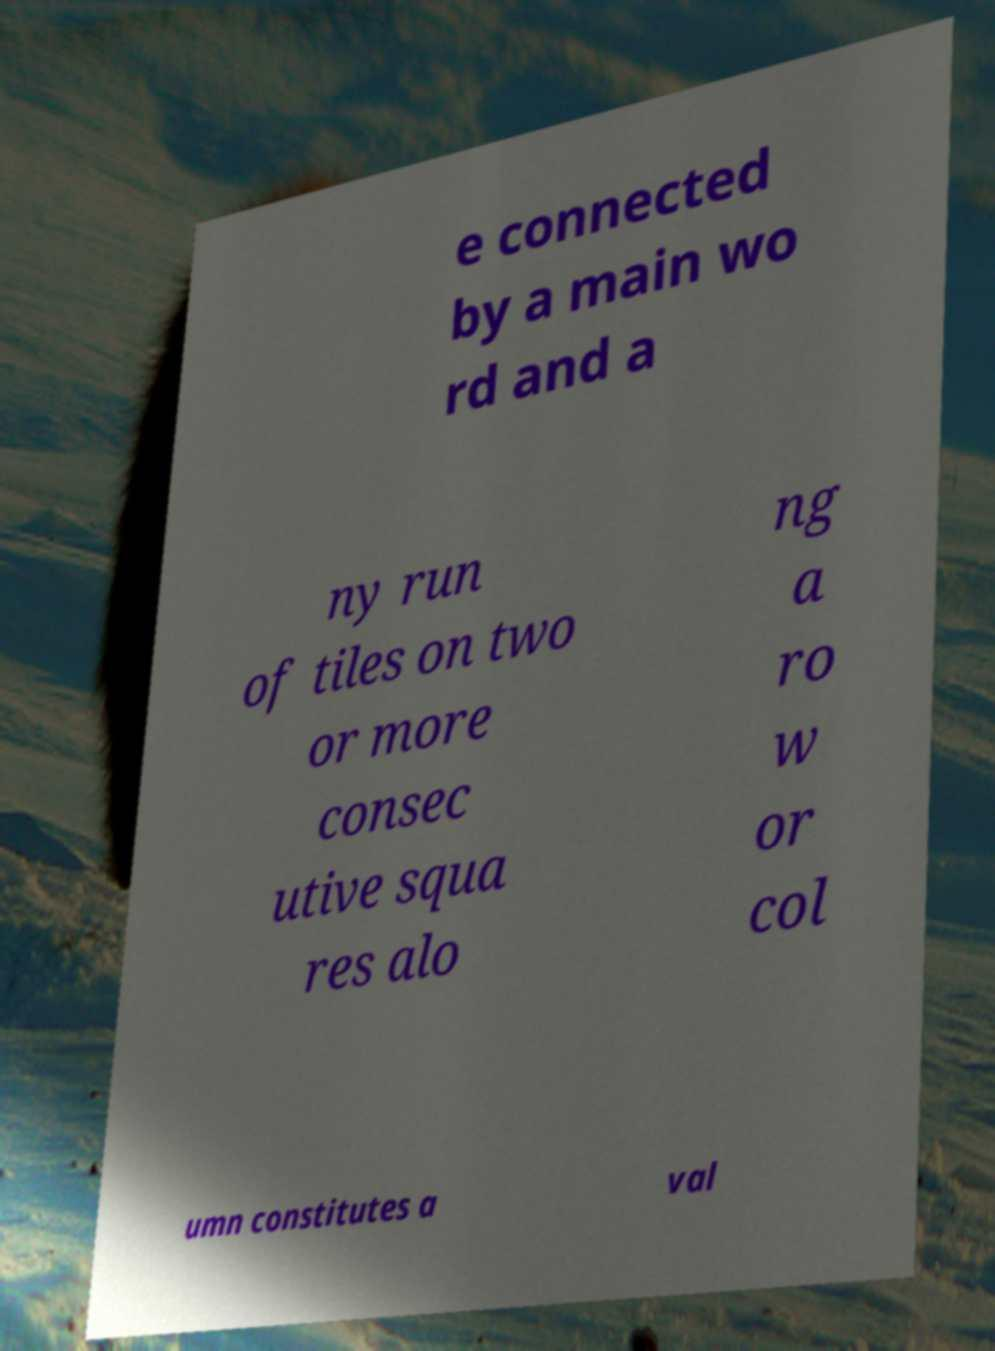For documentation purposes, I need the text within this image transcribed. Could you provide that? e connected by a main wo rd and a ny run of tiles on two or more consec utive squa res alo ng a ro w or col umn constitutes a val 